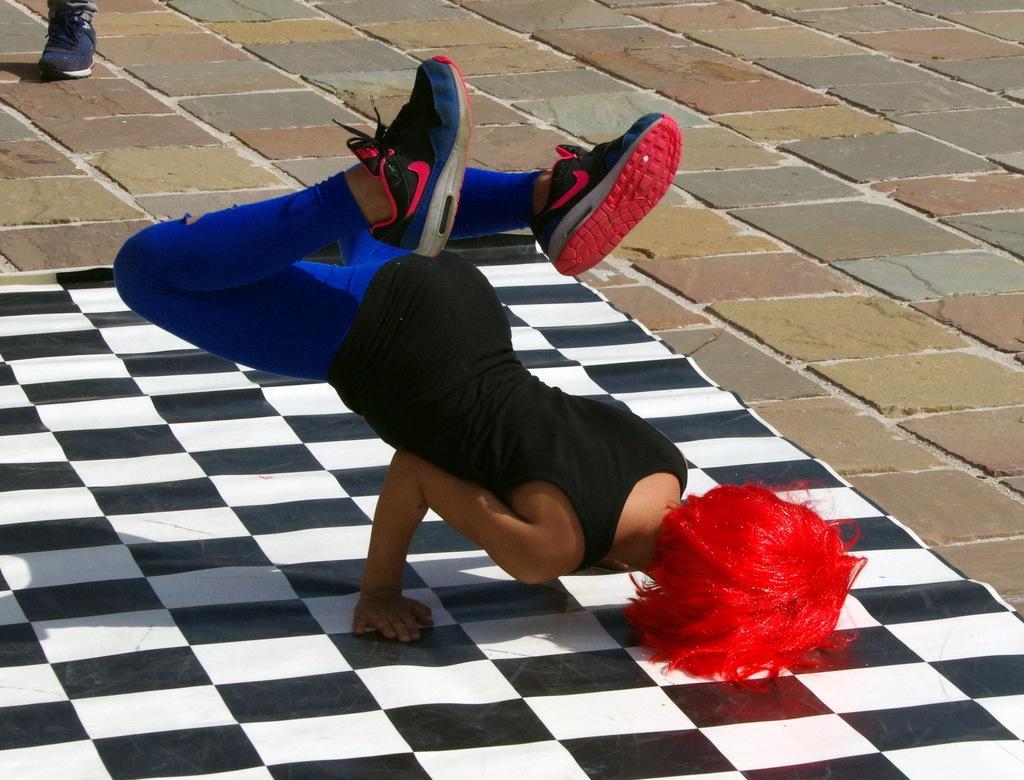In one or two sentences, can you explain what this image depicts? In this picture, we can see a person on the mat and we can see the ground, we can see the leg of a person on the top left corner. 